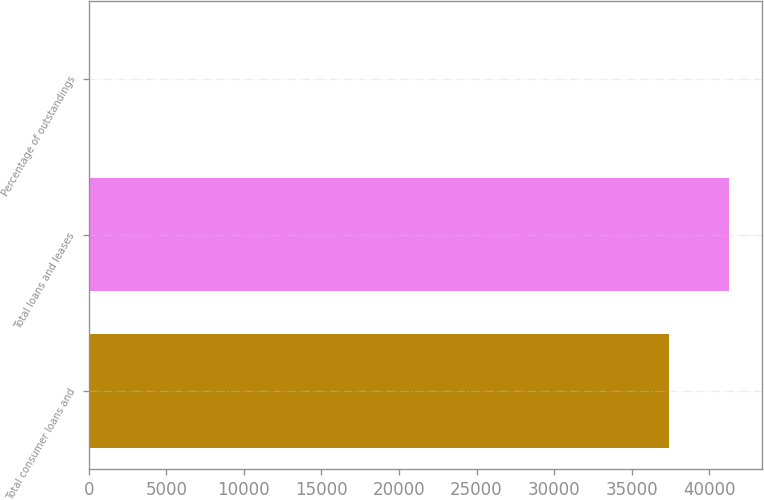Convert chart to OTSL. <chart><loc_0><loc_0><loc_500><loc_500><bar_chart><fcel>Total consumer loans and<fcel>Total loans and leases<fcel>Percentage of outstandings<nl><fcel>37404<fcel>41314.3<fcel>4.21<nl></chart> 